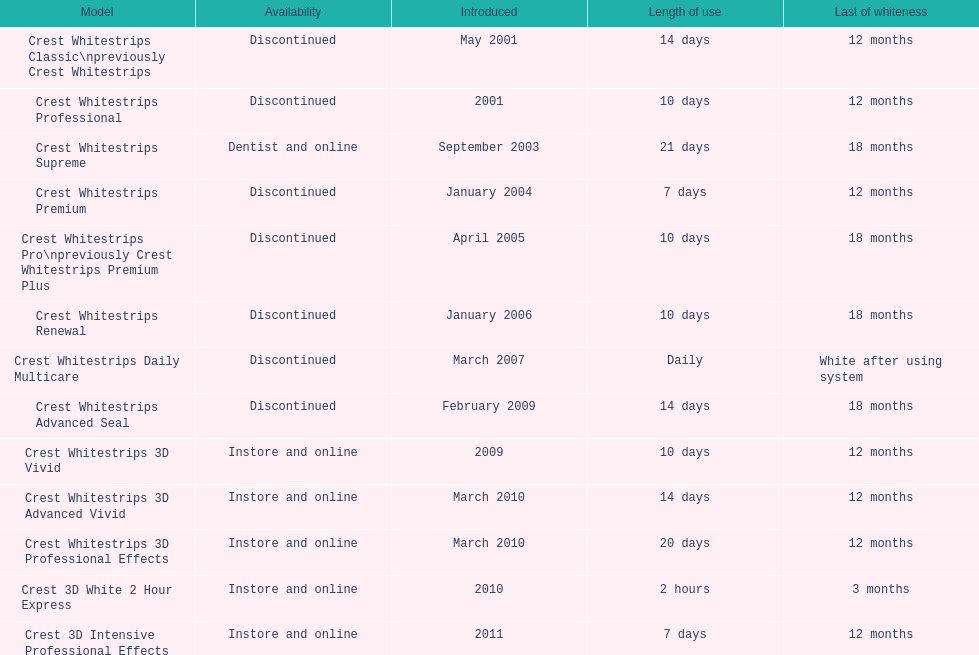What's the total count of discontinued products? 7. 